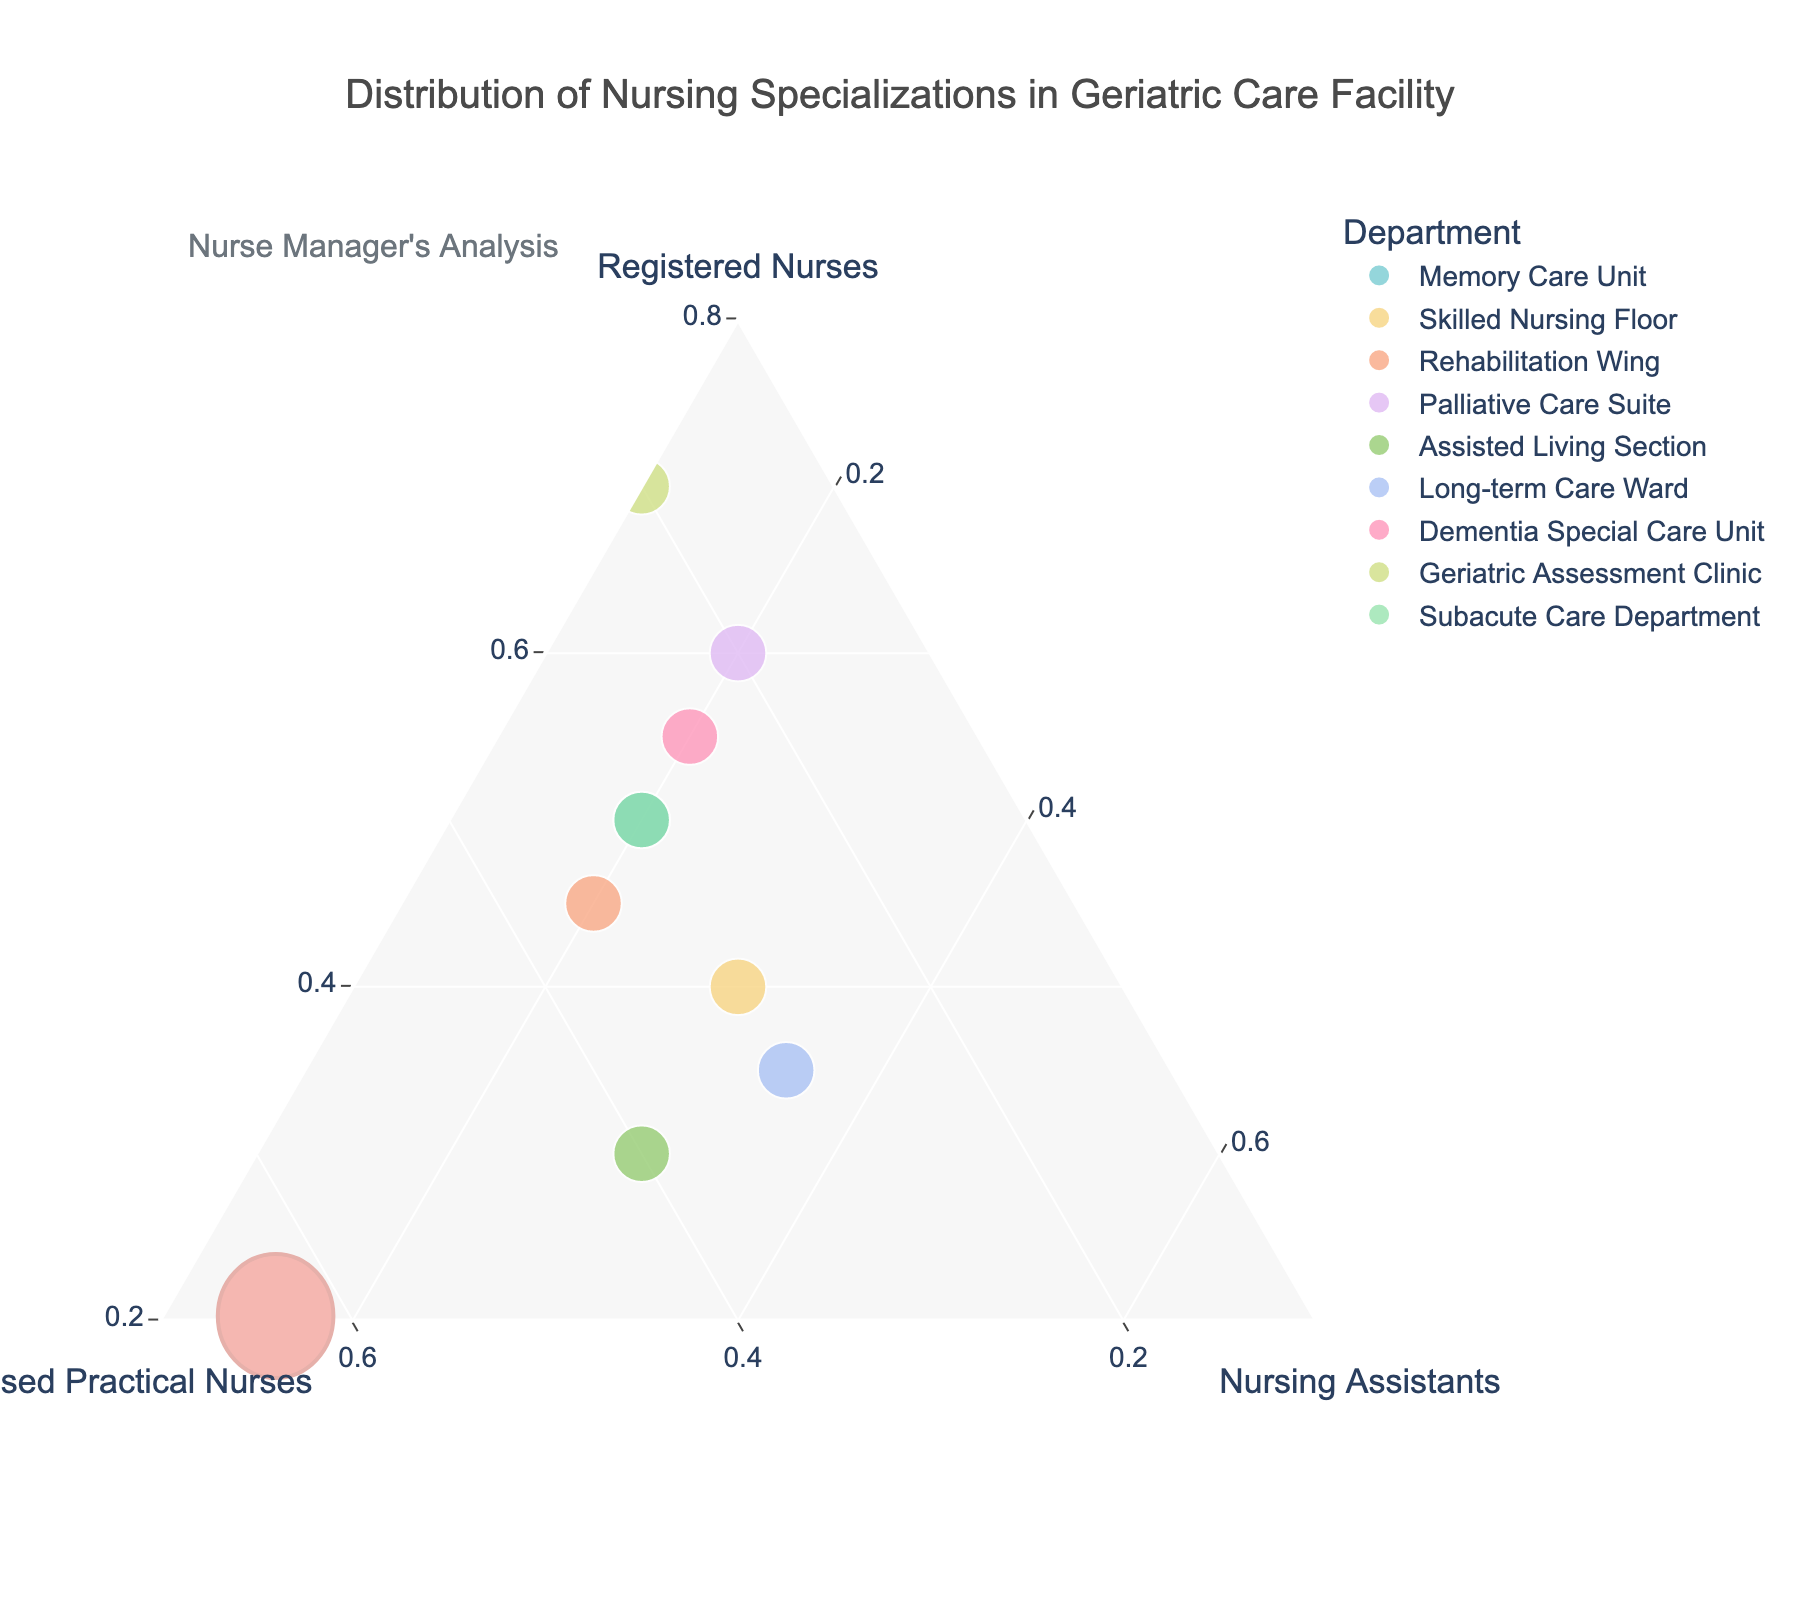What is the title of the plot? The title is usually located at the top of the plot. In this case, it is written in a larger font and centered at the top.
Answer: Distribution of Nursing Specializations in Geriatric Care Facility How many departments are displayed in the plot? To determine the number of departments, count the individual data points or unique entries in the plot legend. Each department is represented by a different color.
Answer: 9 Which department has the highest proportion of Registered Nurses? On a ternary plot, the point nearest to the bottom-left corner (indicating 100% Registered Nurses) holds the highest proportion. This is marked by checking the location of each department's point related to the Registered Nurses axis.
Answer: Geriatric Assessment Clinic Which departments have an equal proportion of Nursing Assistants? Look for points aligned horizontally along the Nursing Assistants axis. Multiple departments situated at the same level on this axis indicate equal proportions.
Answer: Memory Care Unit, Dementia Special Care Unit, and Subacute Care Department How does the proportion of Licensed Practical Nurses compare between the Assisted Living Section and Long-term Care Ward? Compare the vertical positions of the points corresponding to these departments. The point higher on the Licensed Practical Nurses axis has a greater proportion.
Answer: Assisted Living Section has a higher proportion What is the average proportion of Nursing Assistants across all departments? To find the average, sum the proportions of Nursing Assistants across all departments and divide by the total number of departments. (0.2 + 0.3 + 0.2 + 0.2 + 0.3 + 0.35 + 0.2 + 0.1 + 0.2 = 2.05, 2.05 / 9)
Answer: 0.23 Which department is closest to having an equal distribution of all three specializations? An equal distribution of 33.3% each specialization would be located in the center of the ternary plot. Find the point closest to the center.
Answer: Long-term Care Ward Which departments fall within the range of 0.3 to 0.4 proportion for Licensed Practical Nurses? Look for points captured between the 0.3 and 0.4 marks on the Licensed Practical Nurses axis.
Answer: Skilled Nursing Floor, Rehabilitation Wing, Assisted Living Section If a new department had 0.4 Registered Nurses, 0.3 Licensed Practical Nurses, and 0.3 Nursing Assistants, which current department would it be closest to? Place the new point on the ternary plot and find the nearest existing point based on its coordinates. This requires visual comparison of proximity.
Answer: Skilled Nursing Floor 